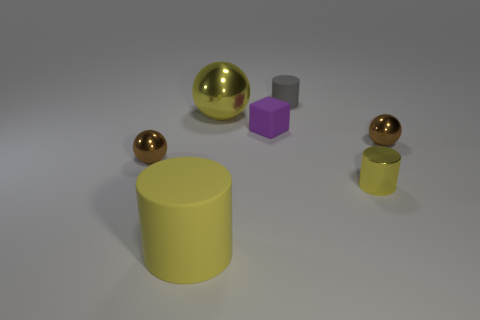Add 1 tiny green matte objects. How many objects exist? 8 Subtract all cubes. How many objects are left? 6 Add 2 small red rubber objects. How many small red rubber objects exist? 2 Subtract 0 blue spheres. How many objects are left? 7 Subtract all big red cylinders. Subtract all gray matte cylinders. How many objects are left? 6 Add 6 shiny things. How many shiny things are left? 10 